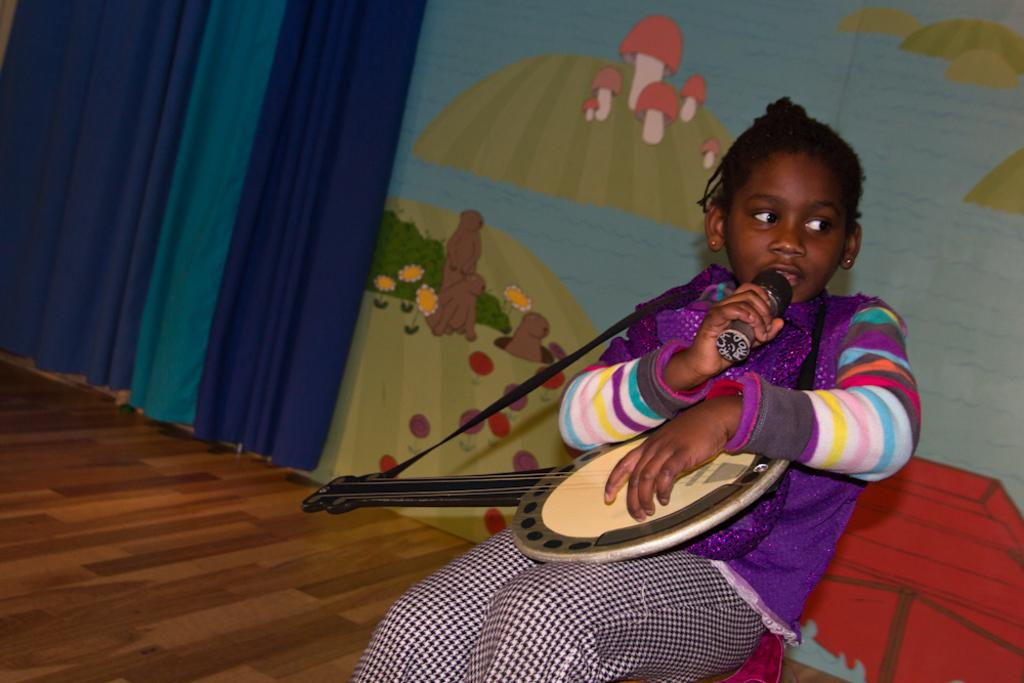What is the main subject of the image? The main subject of the image is a small girl. What is the girl holding in the image? The girl is holding a guitar and a mic. What can be seen in the background of the image? There is a curtain and a painting on the wall in the background. Is the girl performing a business operation while swimming in the image? No, there is no indication of a business operation or swimming in the image. The girl is holding a guitar and a mic, and there is a curtain and a painting on the wall in the background. 